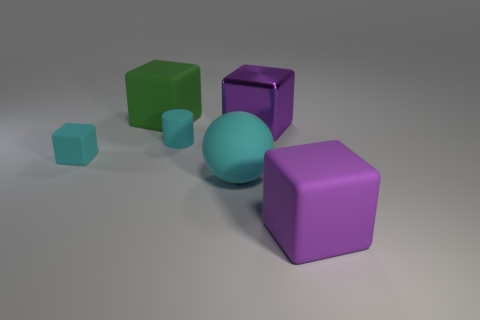What is the size of the cylinder that is the same color as the ball?
Keep it short and to the point. Small. What number of blue things are either matte cylinders or large blocks?
Your response must be concise. 0. How many rubber cubes are in front of the cyan thing to the right of the tiny cylinder?
Your response must be concise. 1. There is a big purple object that is made of the same material as the big green object; what is its shape?
Give a very brief answer. Cube. Do the large sphere and the tiny cylinder have the same color?
Your answer should be very brief. Yes. Are the object that is left of the large green matte block and the big thing left of the cyan cylinder made of the same material?
Offer a terse response. Yes. How many objects are metallic cubes or purple blocks that are in front of the metallic object?
Offer a terse response. 2. What shape is the large rubber object that is the same color as the matte cylinder?
Your response must be concise. Sphere. Are the cyan cylinder and the small block made of the same material?
Make the answer very short. Yes. How many metal objects are large green cubes or tiny blocks?
Make the answer very short. 0. 